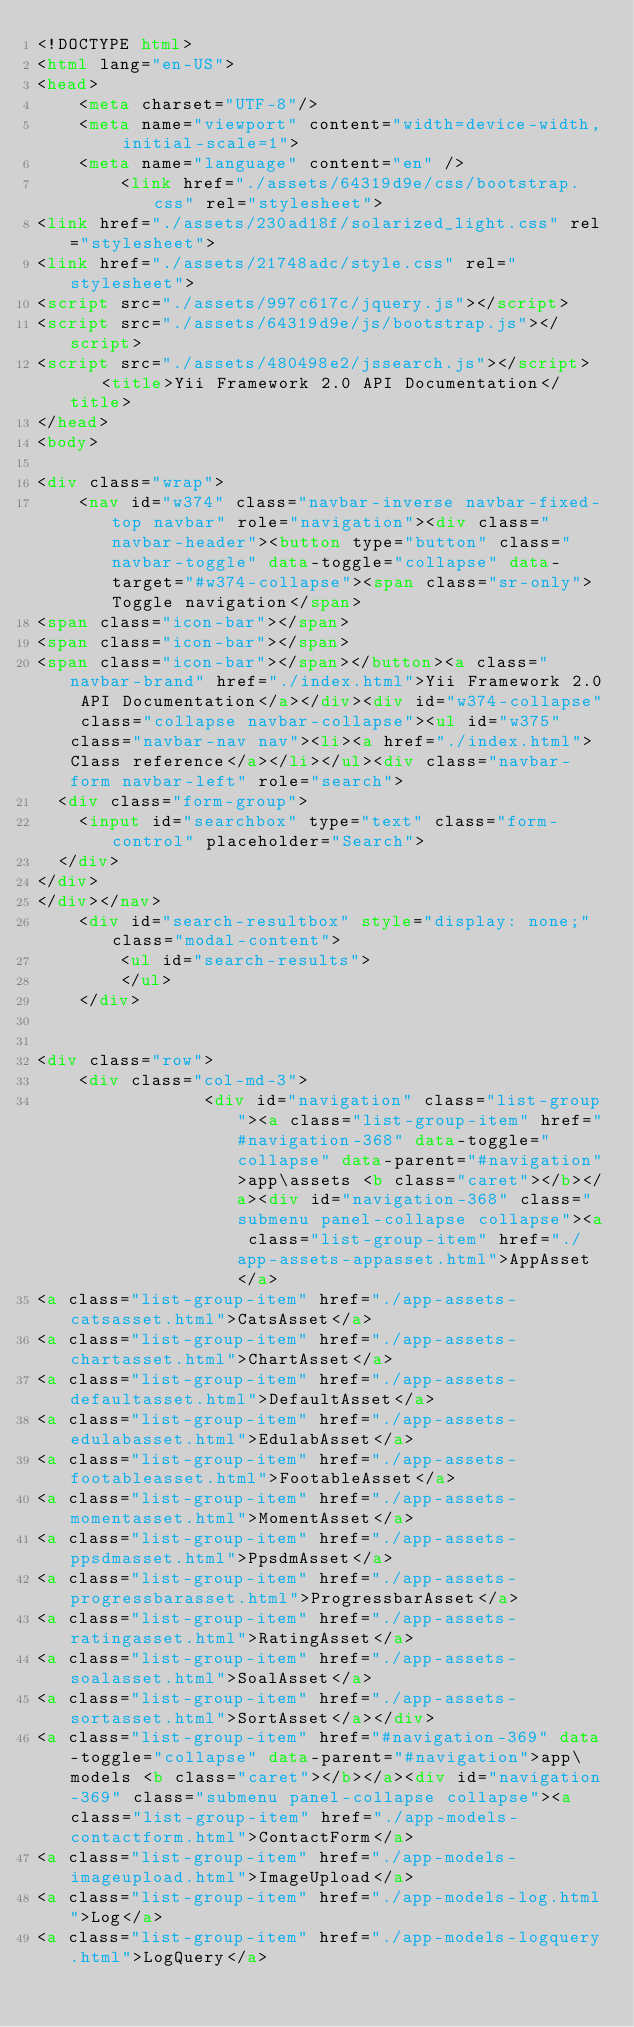<code> <loc_0><loc_0><loc_500><loc_500><_HTML_><!DOCTYPE html>
<html lang="en-US">
<head>
    <meta charset="UTF-8"/>
    <meta name="viewport" content="width=device-width, initial-scale=1">
    <meta name="language" content="en" />
        <link href="./assets/64319d9e/css/bootstrap.css" rel="stylesheet">
<link href="./assets/230ad18f/solarized_light.css" rel="stylesheet">
<link href="./assets/21748adc/style.css" rel="stylesheet">
<script src="./assets/997c617c/jquery.js"></script>
<script src="./assets/64319d9e/js/bootstrap.js"></script>
<script src="./assets/480498e2/jssearch.js"></script>    <title>Yii Framework 2.0 API Documentation</title>
</head>
<body>

<div class="wrap">
    <nav id="w374" class="navbar-inverse navbar-fixed-top navbar" role="navigation"><div class="navbar-header"><button type="button" class="navbar-toggle" data-toggle="collapse" data-target="#w374-collapse"><span class="sr-only">Toggle navigation</span>
<span class="icon-bar"></span>
<span class="icon-bar"></span>
<span class="icon-bar"></span></button><a class="navbar-brand" href="./index.html">Yii Framework 2.0 API Documentation</a></div><div id="w374-collapse" class="collapse navbar-collapse"><ul id="w375" class="navbar-nav nav"><li><a href="./index.html">Class reference</a></li></ul><div class="navbar-form navbar-left" role="search">
  <div class="form-group">
    <input id="searchbox" type="text" class="form-control" placeholder="Search">
  </div>
</div>
</div></nav>
    <div id="search-resultbox" style="display: none;" class="modal-content">
        <ul id="search-results">
        </ul>
    </div>

    
<div class="row">
    <div class="col-md-3">
                <div id="navigation" class="list-group"><a class="list-group-item" href="#navigation-368" data-toggle="collapse" data-parent="#navigation">app\assets <b class="caret"></b></a><div id="navigation-368" class="submenu panel-collapse collapse"><a class="list-group-item" href="./app-assets-appasset.html">AppAsset</a>
<a class="list-group-item" href="./app-assets-catsasset.html">CatsAsset</a>
<a class="list-group-item" href="./app-assets-chartasset.html">ChartAsset</a>
<a class="list-group-item" href="./app-assets-defaultasset.html">DefaultAsset</a>
<a class="list-group-item" href="./app-assets-edulabasset.html">EdulabAsset</a>
<a class="list-group-item" href="./app-assets-footableasset.html">FootableAsset</a>
<a class="list-group-item" href="./app-assets-momentasset.html">MomentAsset</a>
<a class="list-group-item" href="./app-assets-ppsdmasset.html">PpsdmAsset</a>
<a class="list-group-item" href="./app-assets-progressbarasset.html">ProgressbarAsset</a>
<a class="list-group-item" href="./app-assets-ratingasset.html">RatingAsset</a>
<a class="list-group-item" href="./app-assets-soalasset.html">SoalAsset</a>
<a class="list-group-item" href="./app-assets-sortasset.html">SortAsset</a></div>
<a class="list-group-item" href="#navigation-369" data-toggle="collapse" data-parent="#navigation">app\models <b class="caret"></b></a><div id="navigation-369" class="submenu panel-collapse collapse"><a class="list-group-item" href="./app-models-contactform.html">ContactForm</a>
<a class="list-group-item" href="./app-models-imageupload.html">ImageUpload</a>
<a class="list-group-item" href="./app-models-log.html">Log</a>
<a class="list-group-item" href="./app-models-logquery.html">LogQuery</a></code> 